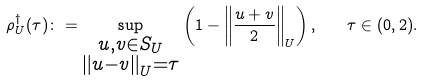<formula> <loc_0><loc_0><loc_500><loc_500>\rho ^ { \dagger } _ { U } ( \tau ) \colon = \sup _ { \substack { u , v \in S _ { U } \\ \left \| u - v \right \| _ { U } = \tau } } \left ( 1 - \left \| \frac { u + v } { 2 } \right \| _ { U } \right ) , \quad \tau \in ( 0 , 2 ) .</formula> 